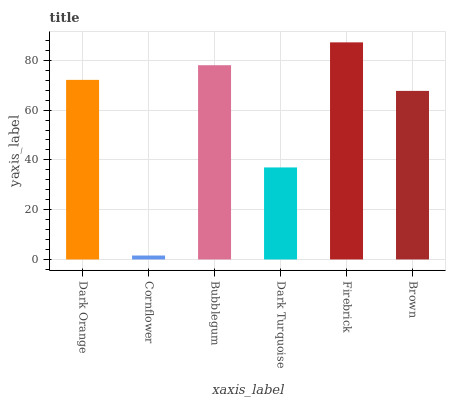Is Cornflower the minimum?
Answer yes or no. Yes. Is Firebrick the maximum?
Answer yes or no. Yes. Is Bubblegum the minimum?
Answer yes or no. No. Is Bubblegum the maximum?
Answer yes or no. No. Is Bubblegum greater than Cornflower?
Answer yes or no. Yes. Is Cornflower less than Bubblegum?
Answer yes or no. Yes. Is Cornflower greater than Bubblegum?
Answer yes or no. No. Is Bubblegum less than Cornflower?
Answer yes or no. No. Is Dark Orange the high median?
Answer yes or no. Yes. Is Brown the low median?
Answer yes or no. Yes. Is Cornflower the high median?
Answer yes or no. No. Is Cornflower the low median?
Answer yes or no. No. 